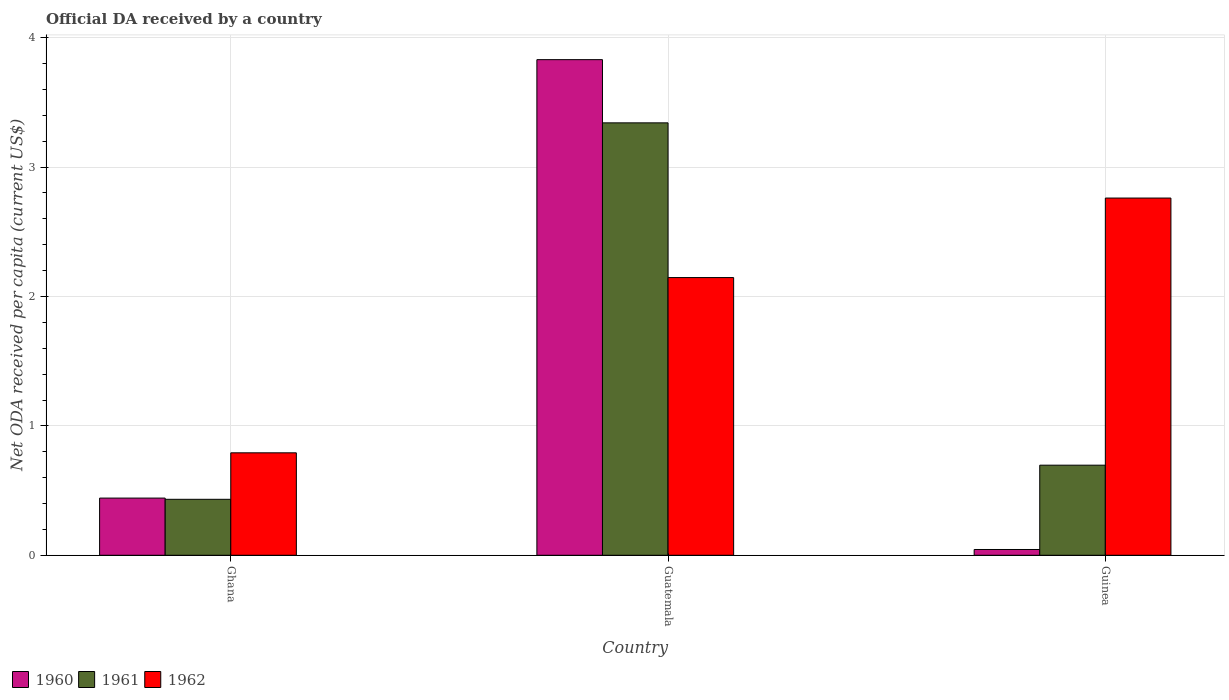How many groups of bars are there?
Make the answer very short. 3. How many bars are there on the 2nd tick from the left?
Your response must be concise. 3. What is the label of the 1st group of bars from the left?
Ensure brevity in your answer.  Ghana. In how many cases, is the number of bars for a given country not equal to the number of legend labels?
Ensure brevity in your answer.  0. What is the ODA received in in 1961 in Guinea?
Your answer should be compact. 0.7. Across all countries, what is the maximum ODA received in in 1961?
Make the answer very short. 3.34. Across all countries, what is the minimum ODA received in in 1960?
Your response must be concise. 0.04. In which country was the ODA received in in 1961 maximum?
Give a very brief answer. Guatemala. In which country was the ODA received in in 1960 minimum?
Provide a succinct answer. Guinea. What is the total ODA received in in 1962 in the graph?
Keep it short and to the point. 5.7. What is the difference between the ODA received in in 1960 in Guatemala and that in Guinea?
Your answer should be compact. 3.79. What is the difference between the ODA received in in 1962 in Ghana and the ODA received in in 1961 in Guinea?
Make the answer very short. 0.1. What is the average ODA received in in 1962 per country?
Give a very brief answer. 1.9. What is the difference between the ODA received in of/in 1960 and ODA received in of/in 1962 in Ghana?
Make the answer very short. -0.35. What is the ratio of the ODA received in in 1961 in Guatemala to that in Guinea?
Give a very brief answer. 4.8. What is the difference between the highest and the second highest ODA received in in 1961?
Keep it short and to the point. 0.26. What is the difference between the highest and the lowest ODA received in in 1962?
Ensure brevity in your answer.  1.97. What does the 1st bar from the right in Guatemala represents?
Keep it short and to the point. 1962. Is it the case that in every country, the sum of the ODA received in in 1960 and ODA received in in 1962 is greater than the ODA received in in 1961?
Your response must be concise. Yes. How many bars are there?
Your response must be concise. 9. Are all the bars in the graph horizontal?
Offer a terse response. No. Are the values on the major ticks of Y-axis written in scientific E-notation?
Make the answer very short. No. Does the graph contain any zero values?
Provide a short and direct response. No. Where does the legend appear in the graph?
Offer a terse response. Bottom left. What is the title of the graph?
Provide a succinct answer. Official DA received by a country. What is the label or title of the X-axis?
Provide a succinct answer. Country. What is the label or title of the Y-axis?
Ensure brevity in your answer.  Net ODA received per capita (current US$). What is the Net ODA received per capita (current US$) in 1960 in Ghana?
Offer a terse response. 0.44. What is the Net ODA received per capita (current US$) in 1961 in Ghana?
Your answer should be very brief. 0.43. What is the Net ODA received per capita (current US$) of 1962 in Ghana?
Provide a short and direct response. 0.79. What is the Net ODA received per capita (current US$) of 1960 in Guatemala?
Give a very brief answer. 3.83. What is the Net ODA received per capita (current US$) of 1961 in Guatemala?
Provide a succinct answer. 3.34. What is the Net ODA received per capita (current US$) in 1962 in Guatemala?
Make the answer very short. 2.15. What is the Net ODA received per capita (current US$) of 1960 in Guinea?
Your answer should be very brief. 0.04. What is the Net ODA received per capita (current US$) of 1961 in Guinea?
Make the answer very short. 0.7. What is the Net ODA received per capita (current US$) of 1962 in Guinea?
Make the answer very short. 2.76. Across all countries, what is the maximum Net ODA received per capita (current US$) of 1960?
Offer a terse response. 3.83. Across all countries, what is the maximum Net ODA received per capita (current US$) in 1961?
Provide a short and direct response. 3.34. Across all countries, what is the maximum Net ODA received per capita (current US$) in 1962?
Offer a terse response. 2.76. Across all countries, what is the minimum Net ODA received per capita (current US$) in 1960?
Keep it short and to the point. 0.04. Across all countries, what is the minimum Net ODA received per capita (current US$) in 1961?
Keep it short and to the point. 0.43. Across all countries, what is the minimum Net ODA received per capita (current US$) of 1962?
Your response must be concise. 0.79. What is the total Net ODA received per capita (current US$) in 1960 in the graph?
Make the answer very short. 4.32. What is the total Net ODA received per capita (current US$) of 1961 in the graph?
Keep it short and to the point. 4.47. What is the total Net ODA received per capita (current US$) of 1962 in the graph?
Ensure brevity in your answer.  5.7. What is the difference between the Net ODA received per capita (current US$) in 1960 in Ghana and that in Guatemala?
Your answer should be compact. -3.39. What is the difference between the Net ODA received per capita (current US$) in 1961 in Ghana and that in Guatemala?
Keep it short and to the point. -2.91. What is the difference between the Net ODA received per capita (current US$) in 1962 in Ghana and that in Guatemala?
Your response must be concise. -1.35. What is the difference between the Net ODA received per capita (current US$) in 1960 in Ghana and that in Guinea?
Offer a very short reply. 0.4. What is the difference between the Net ODA received per capita (current US$) in 1961 in Ghana and that in Guinea?
Give a very brief answer. -0.26. What is the difference between the Net ODA received per capita (current US$) of 1962 in Ghana and that in Guinea?
Your answer should be compact. -1.97. What is the difference between the Net ODA received per capita (current US$) of 1960 in Guatemala and that in Guinea?
Make the answer very short. 3.79. What is the difference between the Net ODA received per capita (current US$) in 1961 in Guatemala and that in Guinea?
Offer a terse response. 2.65. What is the difference between the Net ODA received per capita (current US$) of 1962 in Guatemala and that in Guinea?
Your response must be concise. -0.61. What is the difference between the Net ODA received per capita (current US$) in 1960 in Ghana and the Net ODA received per capita (current US$) in 1962 in Guatemala?
Ensure brevity in your answer.  -1.7. What is the difference between the Net ODA received per capita (current US$) of 1961 in Ghana and the Net ODA received per capita (current US$) of 1962 in Guatemala?
Keep it short and to the point. -1.71. What is the difference between the Net ODA received per capita (current US$) in 1960 in Ghana and the Net ODA received per capita (current US$) in 1961 in Guinea?
Offer a very short reply. -0.25. What is the difference between the Net ODA received per capita (current US$) in 1960 in Ghana and the Net ODA received per capita (current US$) in 1962 in Guinea?
Provide a succinct answer. -2.32. What is the difference between the Net ODA received per capita (current US$) in 1961 in Ghana and the Net ODA received per capita (current US$) in 1962 in Guinea?
Provide a short and direct response. -2.33. What is the difference between the Net ODA received per capita (current US$) in 1960 in Guatemala and the Net ODA received per capita (current US$) in 1961 in Guinea?
Give a very brief answer. 3.13. What is the difference between the Net ODA received per capita (current US$) of 1960 in Guatemala and the Net ODA received per capita (current US$) of 1962 in Guinea?
Offer a terse response. 1.07. What is the difference between the Net ODA received per capita (current US$) in 1961 in Guatemala and the Net ODA received per capita (current US$) in 1962 in Guinea?
Offer a very short reply. 0.58. What is the average Net ODA received per capita (current US$) of 1960 per country?
Ensure brevity in your answer.  1.44. What is the average Net ODA received per capita (current US$) in 1961 per country?
Your answer should be very brief. 1.49. What is the average Net ODA received per capita (current US$) of 1962 per country?
Provide a succinct answer. 1.9. What is the difference between the Net ODA received per capita (current US$) of 1960 and Net ODA received per capita (current US$) of 1961 in Ghana?
Provide a short and direct response. 0.01. What is the difference between the Net ODA received per capita (current US$) in 1960 and Net ODA received per capita (current US$) in 1962 in Ghana?
Give a very brief answer. -0.35. What is the difference between the Net ODA received per capita (current US$) of 1961 and Net ODA received per capita (current US$) of 1962 in Ghana?
Provide a short and direct response. -0.36. What is the difference between the Net ODA received per capita (current US$) of 1960 and Net ODA received per capita (current US$) of 1961 in Guatemala?
Offer a very short reply. 0.49. What is the difference between the Net ODA received per capita (current US$) of 1960 and Net ODA received per capita (current US$) of 1962 in Guatemala?
Provide a short and direct response. 1.68. What is the difference between the Net ODA received per capita (current US$) of 1961 and Net ODA received per capita (current US$) of 1962 in Guatemala?
Offer a very short reply. 1.2. What is the difference between the Net ODA received per capita (current US$) of 1960 and Net ODA received per capita (current US$) of 1961 in Guinea?
Give a very brief answer. -0.65. What is the difference between the Net ODA received per capita (current US$) in 1960 and Net ODA received per capita (current US$) in 1962 in Guinea?
Make the answer very short. -2.72. What is the difference between the Net ODA received per capita (current US$) in 1961 and Net ODA received per capita (current US$) in 1962 in Guinea?
Make the answer very short. -2.06. What is the ratio of the Net ODA received per capita (current US$) in 1960 in Ghana to that in Guatemala?
Ensure brevity in your answer.  0.12. What is the ratio of the Net ODA received per capita (current US$) of 1961 in Ghana to that in Guatemala?
Your answer should be very brief. 0.13. What is the ratio of the Net ODA received per capita (current US$) of 1962 in Ghana to that in Guatemala?
Make the answer very short. 0.37. What is the ratio of the Net ODA received per capita (current US$) of 1960 in Ghana to that in Guinea?
Offer a terse response. 9.88. What is the ratio of the Net ODA received per capita (current US$) in 1961 in Ghana to that in Guinea?
Keep it short and to the point. 0.62. What is the ratio of the Net ODA received per capita (current US$) of 1962 in Ghana to that in Guinea?
Provide a succinct answer. 0.29. What is the ratio of the Net ODA received per capita (current US$) in 1960 in Guatemala to that in Guinea?
Your response must be concise. 85.64. What is the ratio of the Net ODA received per capita (current US$) of 1961 in Guatemala to that in Guinea?
Ensure brevity in your answer.  4.8. What is the ratio of the Net ODA received per capita (current US$) of 1962 in Guatemala to that in Guinea?
Your answer should be very brief. 0.78. What is the difference between the highest and the second highest Net ODA received per capita (current US$) of 1960?
Offer a very short reply. 3.39. What is the difference between the highest and the second highest Net ODA received per capita (current US$) of 1961?
Your answer should be compact. 2.65. What is the difference between the highest and the second highest Net ODA received per capita (current US$) of 1962?
Your response must be concise. 0.61. What is the difference between the highest and the lowest Net ODA received per capita (current US$) of 1960?
Offer a terse response. 3.79. What is the difference between the highest and the lowest Net ODA received per capita (current US$) in 1961?
Keep it short and to the point. 2.91. What is the difference between the highest and the lowest Net ODA received per capita (current US$) in 1962?
Make the answer very short. 1.97. 